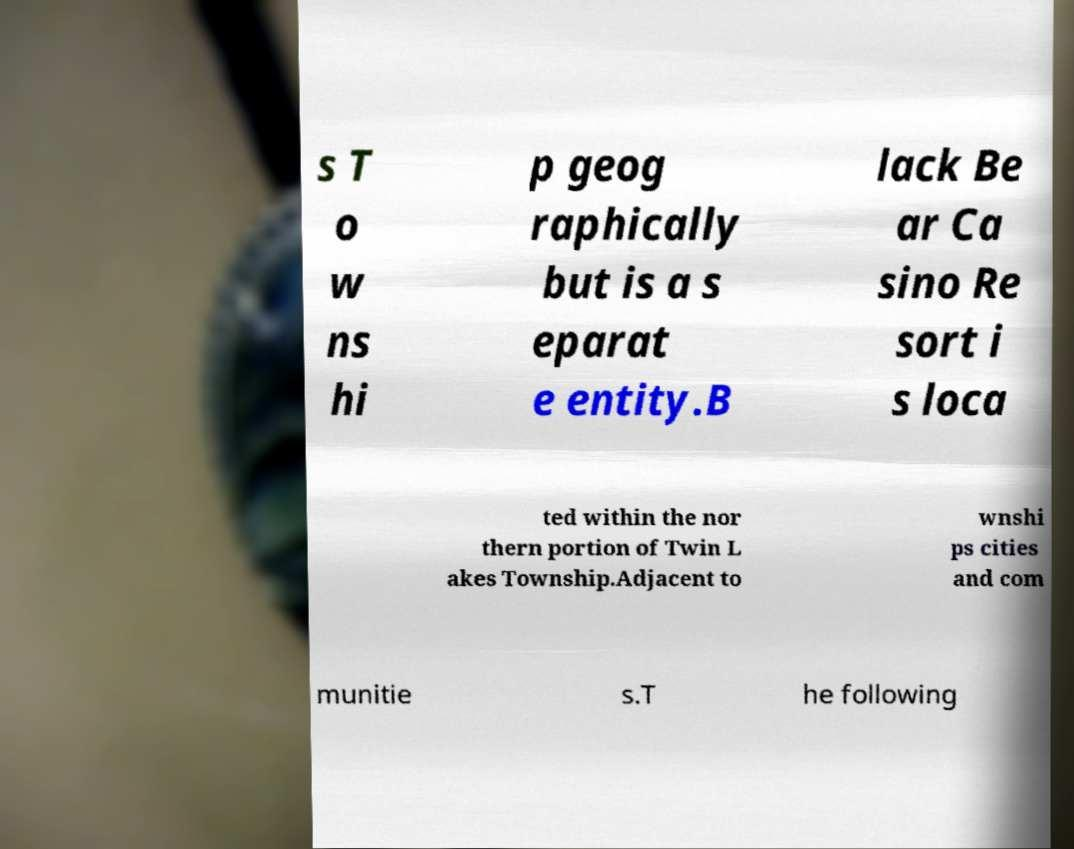Could you assist in decoding the text presented in this image and type it out clearly? s T o w ns hi p geog raphically but is a s eparat e entity.B lack Be ar Ca sino Re sort i s loca ted within the nor thern portion of Twin L akes Township.Adjacent to wnshi ps cities and com munitie s.T he following 